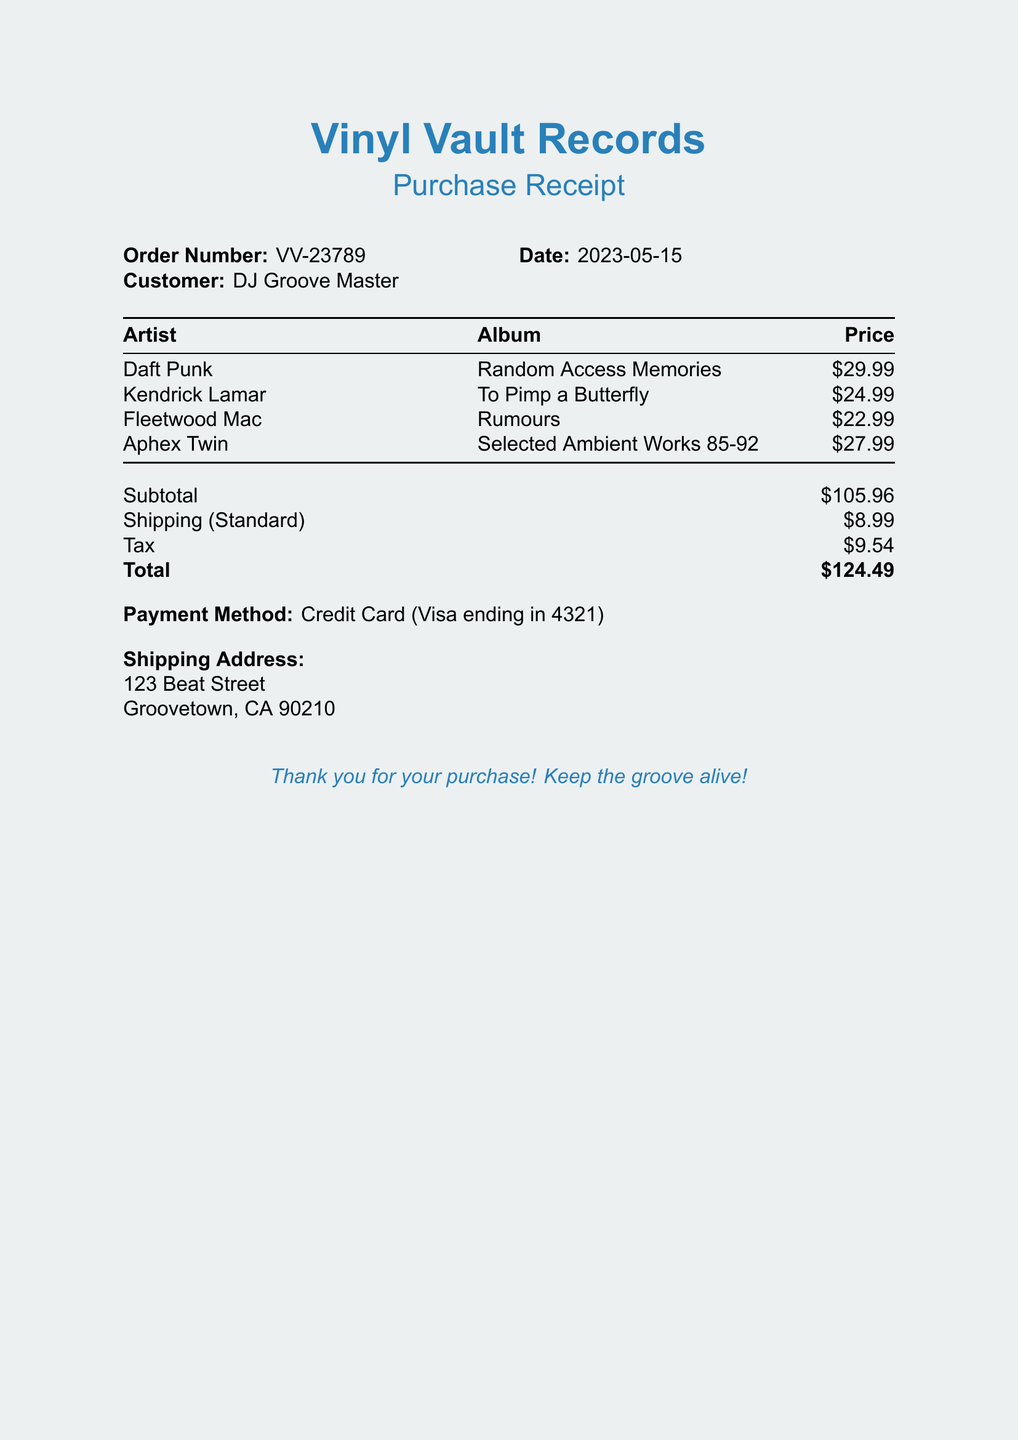What is the order number? The order number is located at the top of the receipt.
Answer: VV-23789 Who is the customer? The customer's name is stated alongside the order number.
Answer: DJ Groove Master What is the subtotal? The subtotal is listed in the billing section of the document.
Answer: $105.96 How much is the shipping cost? The shipping cost is specified below the subtotal in the document.
Answer: $8.99 Which artist has the most expensive album listed? To determine this, compare the prices of the albums.
Answer: Daft Punk What is the date of the purchase? The date of the purchase is mentioned right next to the order number.
Answer: 2023-05-15 What is the total amount charged? The total amount is clearly highlighted at the end of the billing section.
Answer: $124.49 What payment method was used? The payment method is mentioned towards the end of the document.
Answer: Credit Card What is the shipping address? The shipping address is provided directly in the receipt.
Answer: 123 Beat Street, Groovetown, CA 90210 